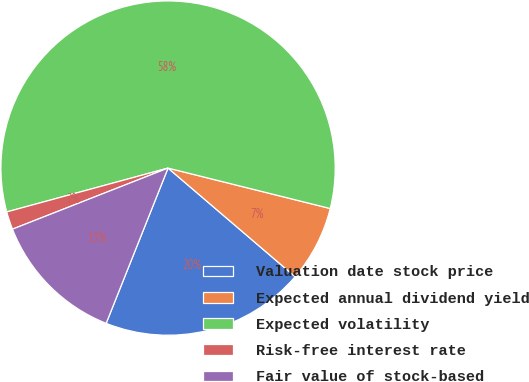Convert chart to OTSL. <chart><loc_0><loc_0><loc_500><loc_500><pie_chart><fcel>Valuation date stock price<fcel>Expected annual dividend yield<fcel>Expected volatility<fcel>Risk-free interest rate<fcel>Fair value of stock-based<nl><fcel>19.78%<fcel>7.37%<fcel>58.12%<fcel>1.73%<fcel>13.01%<nl></chart> 